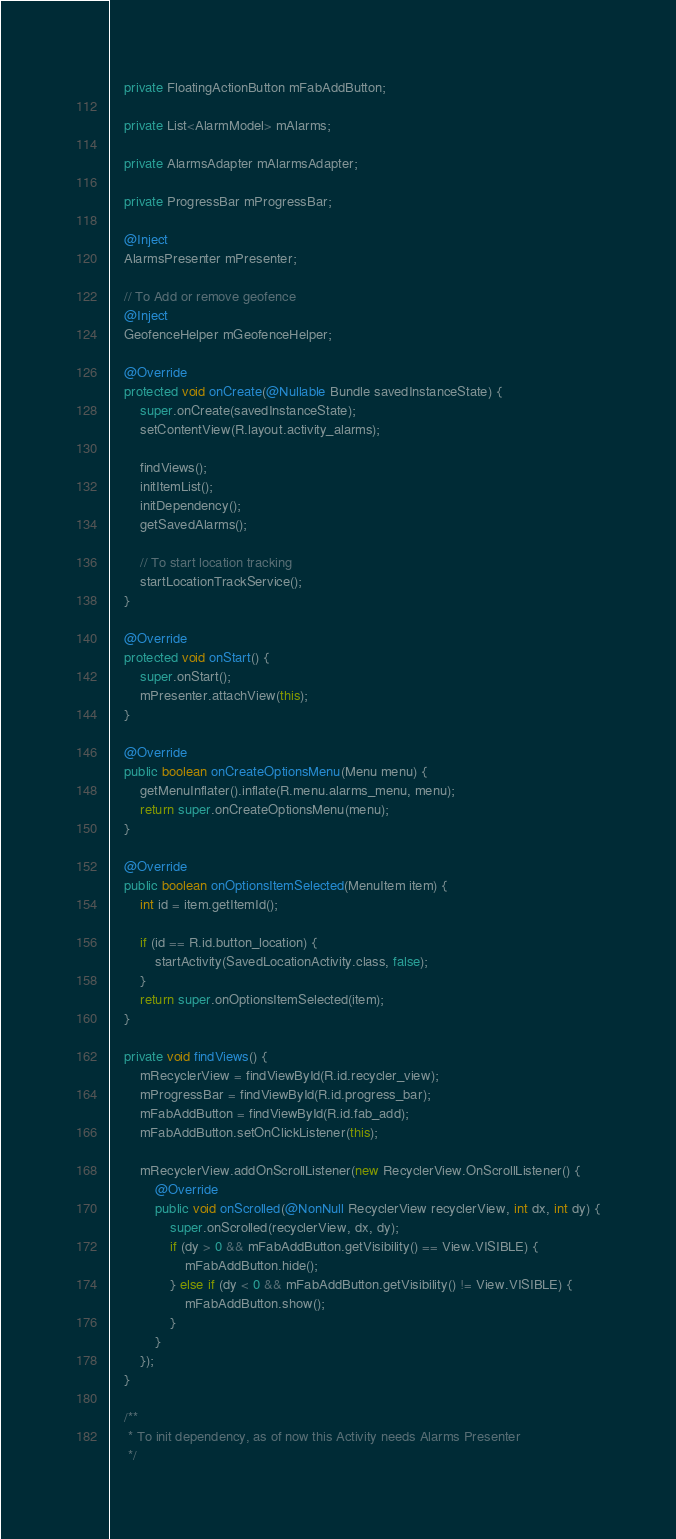<code> <loc_0><loc_0><loc_500><loc_500><_Java_>
    private FloatingActionButton mFabAddButton;

    private List<AlarmModel> mAlarms;

    private AlarmsAdapter mAlarmsAdapter;

    private ProgressBar mProgressBar;

    @Inject
    AlarmsPresenter mPresenter;

    // To Add or remove geofence
    @Inject
    GeofenceHelper mGeofenceHelper;

    @Override
    protected void onCreate(@Nullable Bundle savedInstanceState) {
        super.onCreate(savedInstanceState);
        setContentView(R.layout.activity_alarms);

        findViews();
        initItemList();
        initDependency();
        getSavedAlarms();

        // To start location tracking
        startLocationTrackService();
    }

    @Override
    protected void onStart() {
        super.onStart();
        mPresenter.attachView(this);
    }

    @Override
    public boolean onCreateOptionsMenu(Menu menu) {
        getMenuInflater().inflate(R.menu.alarms_menu, menu);
        return super.onCreateOptionsMenu(menu);
    }

    @Override
    public boolean onOptionsItemSelected(MenuItem item) {
        int id = item.getItemId();

        if (id == R.id.button_location) {
            startActivity(SavedLocationActivity.class, false);
        }
        return super.onOptionsItemSelected(item);
    }

    private void findViews() {
        mRecyclerView = findViewById(R.id.recycler_view);
        mProgressBar = findViewById(R.id.progress_bar);
        mFabAddButton = findViewById(R.id.fab_add);
        mFabAddButton.setOnClickListener(this);

        mRecyclerView.addOnScrollListener(new RecyclerView.OnScrollListener() {
            @Override
            public void onScrolled(@NonNull RecyclerView recyclerView, int dx, int dy) {
                super.onScrolled(recyclerView, dx, dy);
                if (dy > 0 && mFabAddButton.getVisibility() == View.VISIBLE) {
                    mFabAddButton.hide();
                } else if (dy < 0 && mFabAddButton.getVisibility() != View.VISIBLE) {
                    mFabAddButton.show();
                }
            }
        });
    }

    /**
     * To init dependency, as of now this Activity needs Alarms Presenter
     */</code> 